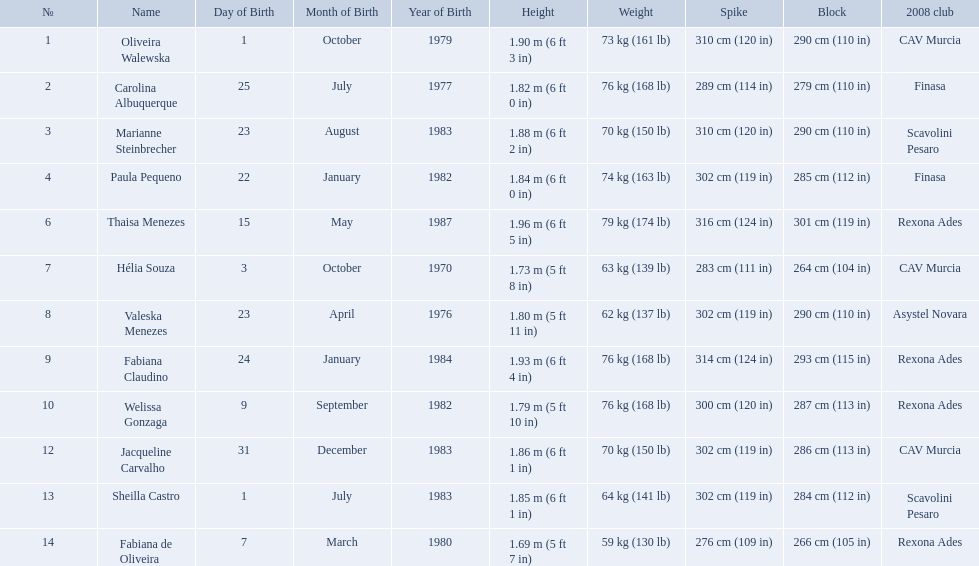How much does fabiana de oliveira weigh? 76 kg (168 lb). How much does helia souza weigh? 63 kg (139 lb). How much does sheilla castro weigh? 64 kg (141 lb). Whose weight did the original question asker incorrectly believe to be the heaviest (they are the second heaviest)? Sheilla Castro. What are the names of all the contestants? Oliveira Walewska, Carolina Albuquerque, Marianne Steinbrecher, Paula Pequeno, Thaisa Menezes, Hélia Souza, Valeska Menezes, Fabiana Claudino, Welissa Gonzaga, Jacqueline Carvalho, Sheilla Castro, Fabiana de Oliveira. What are the weight ranges of the contestants? 73 kg (161 lb), 76 kg (168 lb), 70 kg (150 lb), 74 kg (163 lb), 79 kg (174 lb), 63 kg (139 lb), 62 kg (137 lb), 76 kg (168 lb), 76 kg (168 lb), 70 kg (150 lb), 64 kg (141 lb), 59 kg (130 lb). Which player is heaviest. sheilla castro, fabiana de oliveira, or helia souza? Sheilla Castro. 